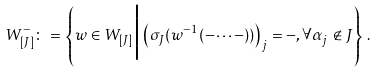<formula> <loc_0><loc_0><loc_500><loc_500>W _ { [ J ] } ^ { - } \colon = \left \{ w \in W _ { [ J ] } \Big | \left ( \sigma _ { J } ( w ^ { - 1 } ( - \cdots - ) ) \right ) _ { j } = - , \forall \alpha _ { j } \notin J \right \} \, .</formula> 